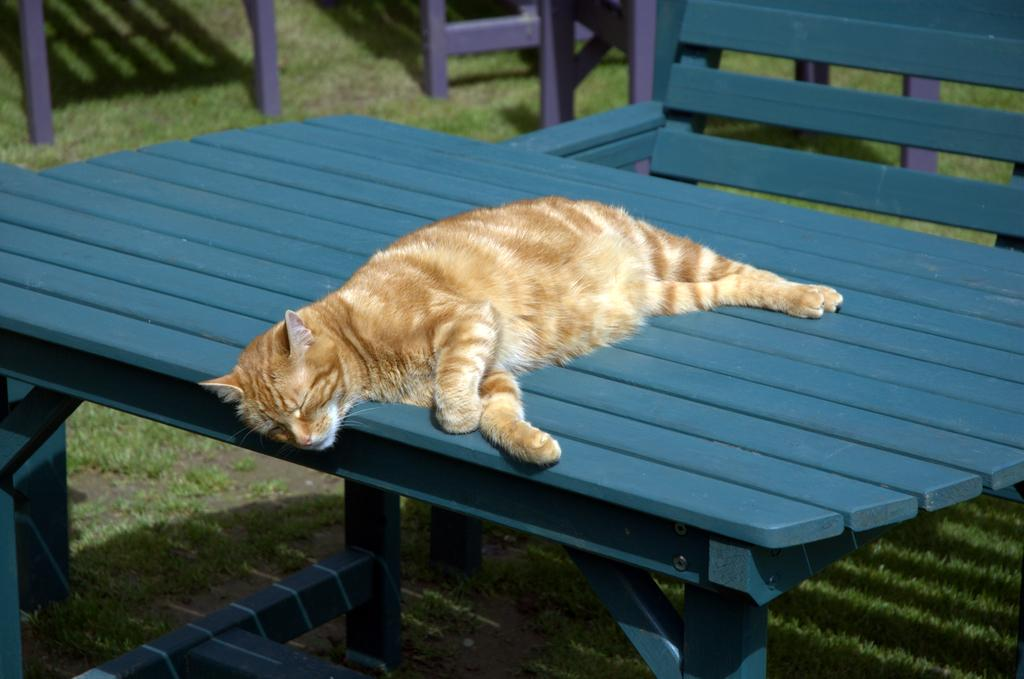What animal can be seen in the image? There is a cat sleeping on a table in the image. What color are the table and bench? The table and bench are blue. What type of vegetation is visible in the image? Grass is visible and is green. What type of seating is present in the image? There is a bench in the image. What type of milk is the cat drinking from the vest in the image? There is no milk or vest present in the image; the cat is sleeping on a table. 